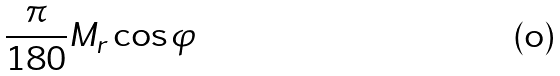Convert formula to latex. <formula><loc_0><loc_0><loc_500><loc_500>\frac { \pi } { 1 8 0 } M _ { r } \cos \varphi</formula> 